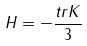<formula> <loc_0><loc_0><loc_500><loc_500>H = - \frac { t r K } { 3 }</formula> 